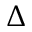Convert formula to latex. <formula><loc_0><loc_0><loc_500><loc_500>\Delta</formula> 